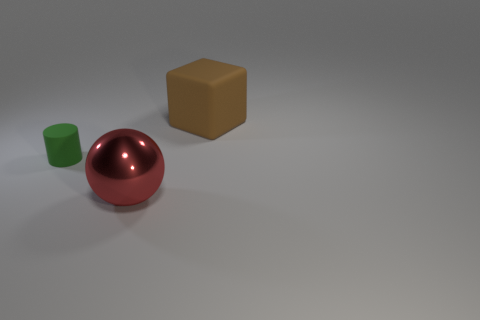There is a red ball; does it have the same size as the matte thing that is to the right of the tiny green thing? Based on the image, the red ball appears to be larger in size compared to the matte brown cube that is positioned to the right of the small green cylinder. 